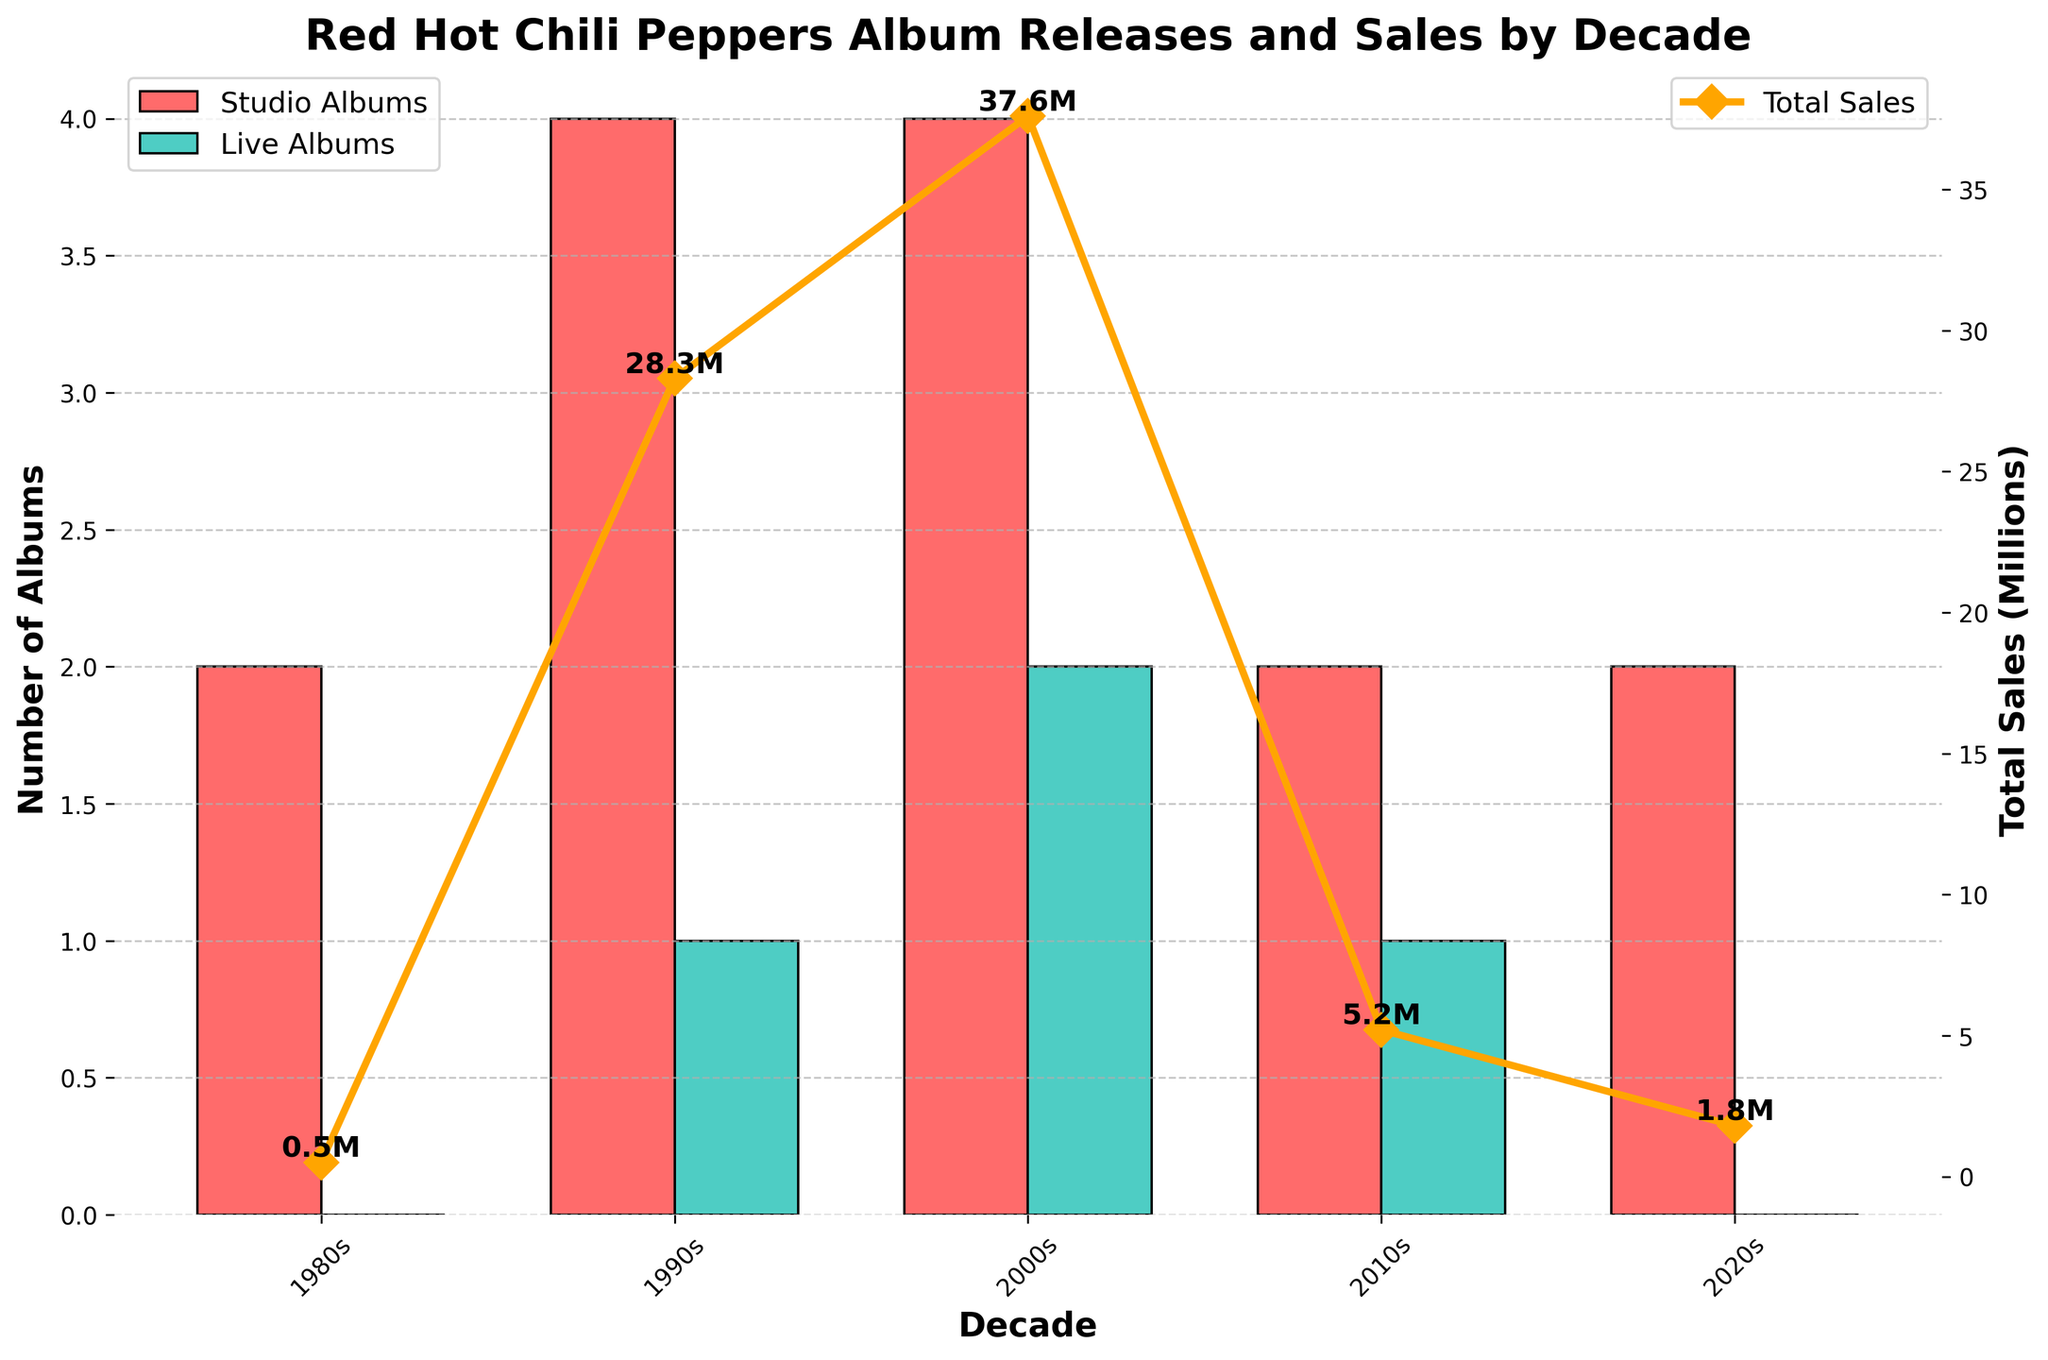Which decade had the highest total album sales? The 2000s decade has the highest "Total Sales (Millions)" value, which is represented by the highest data point in the orange line plot.
Answer: 2000s Which bars represent the number of live albums released in the 2010s? The bars for live albums are colored green. Look for the green bar in the 2010s decade on the x-axis.
Answer: Green bar in 2010s By how much did total album sales increase from the 1980s to the 1990s? Find the total sales data points for both decades. 1990s have 28.3 million, and 1980s have 0.5 million. The increase is 28.3 - 0.5 = 27.8 million.
Answer: 27.8 million How did studio album releases compare between the 1990s and 2000s? The number of studio albums is represented by red bars. Compare the heights of the red bars in the 1990s and 2000s. Both have the same number of studio albums, 4 each.
Answer: Equal (4 each) What's the combined total sales for the 2000s and 2010s? Total sales for 2000s is 37.6 million, and for 2010s is 5.2 million. Summing these values: 37.6 + 5.2 = 42.8 million
Answer: 42.8 million Which decade saw the biggest number of live album releases? The number of live albums is represented by green bars. The decade with the tallest green bar has the most live albums. The 2000s decade has the highest green bar (2 live albums).
Answer: 2000s What is the difference in the number of album releases (both studio and live) between the 1980s and 2020s? 1980s had 2 studio albums and 0 live albums, total 2. 2020s had 2 studio albums and 0 live albums, total 2. The difference is 2 - 2 = 0.
Answer: 0 What is the average total sales per album in the 2000s? In the 2000s, there are 4 studio albums and 2 live albums, totaling 6 albums. Total sales in the 2000s is 37.6 million. The average is 37.6 / 6 ≈ 6.27 million per album.
Answer: 6.27 million per album Compare total album sales between the decades with only 2 studio albums. Which one is higher? Decades with 2 studio albums are the 1980s, 2010s, and 2020s. Compare their total sales: 1980s (0.5 million), 2010s (5.2 million), 2020s (1.8 million). 2010s have the highest total sales.
Answer: 2010s 